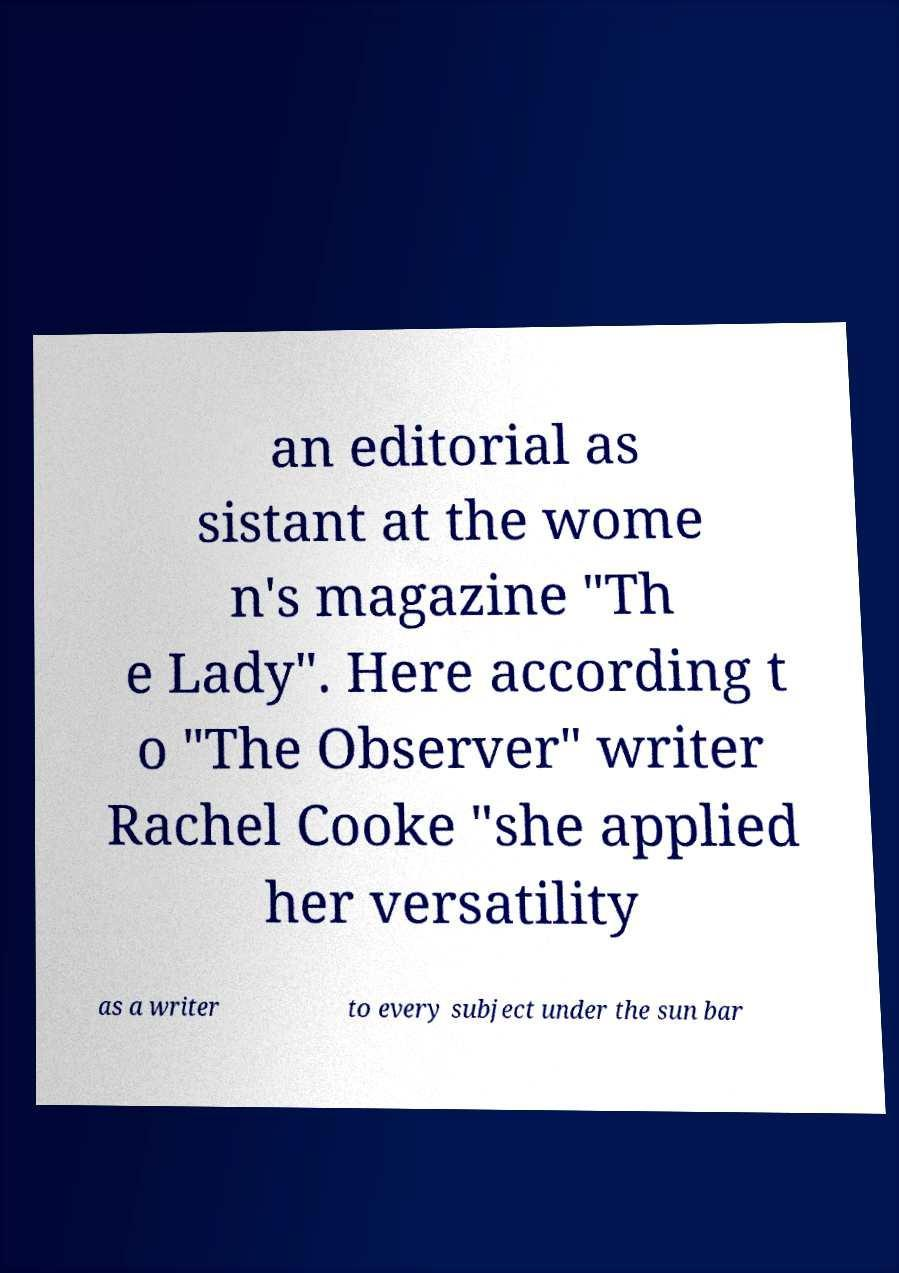Can you accurately transcribe the text from the provided image for me? an editorial as sistant at the wome n's magazine "Th e Lady". Here according t o "The Observer" writer Rachel Cooke "she applied her versatility as a writer to every subject under the sun bar 